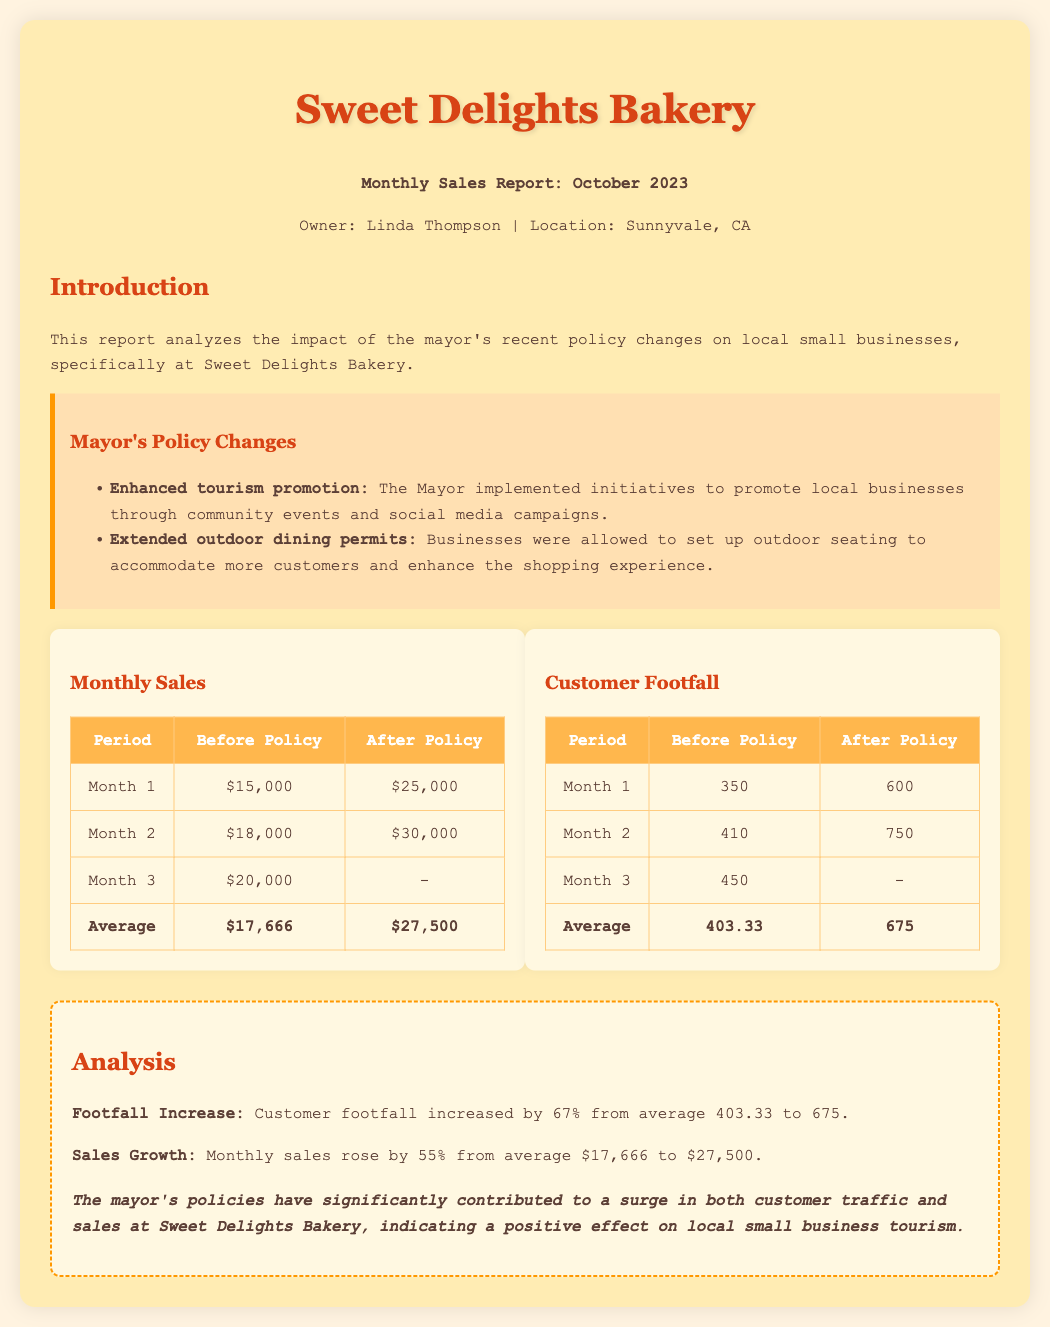What is the average sales before the policy? The average sales before the policy is provided in the metrics section, which states $17,666.
Answer: $17,666 What is the average footfall after the policy? The average footfall after the policy is indicated in the customer footfall table, which shows 675.
Answer: 675 How much did monthly sales increase on average after the policy? The sales growth from the analysis section states an increase from $17,666 to $27,500, which is $27,500.
Answer: $27,500 What was the customer footfall in Month 2 before the policy? The customer footfall table specifies that in Month 2 before the policy it was 410.
Answer: 410 What percentage increase did footfall experience after the policy? The analysis mentions a 67% increase in footfall from 403.33 to 675.
Answer: 67% What two main policies did the mayor implement? The mayor's policy changes outlined in the document are "Enhanced tourism promotion" and "Extended outdoor dining permits."
Answer: Enhanced tourism promotion, Extended outdoor dining permits What was the customer footfall in Month 1 after the policy? The customer footfall table shows that in Month 1 after the policy it was 600.
Answer: 600 What is the total number of months analyzed in the report? The report analyzes data over three months before and after the policy, as shown in the tables.
Answer: 3 What colors are used for the header section of the document? The document uses #D84315 for headers, with a background color of #FFECB3.
Answer: #D84315, #FFECB3 